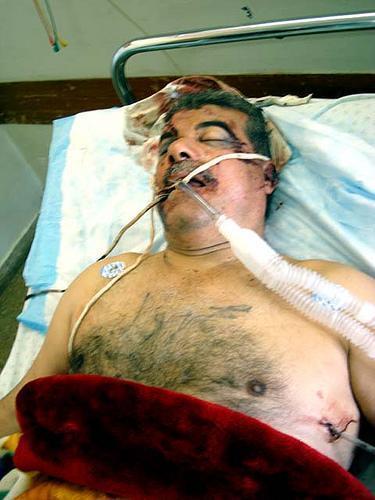How many patients are in the picture?
Give a very brief answer. 1. 